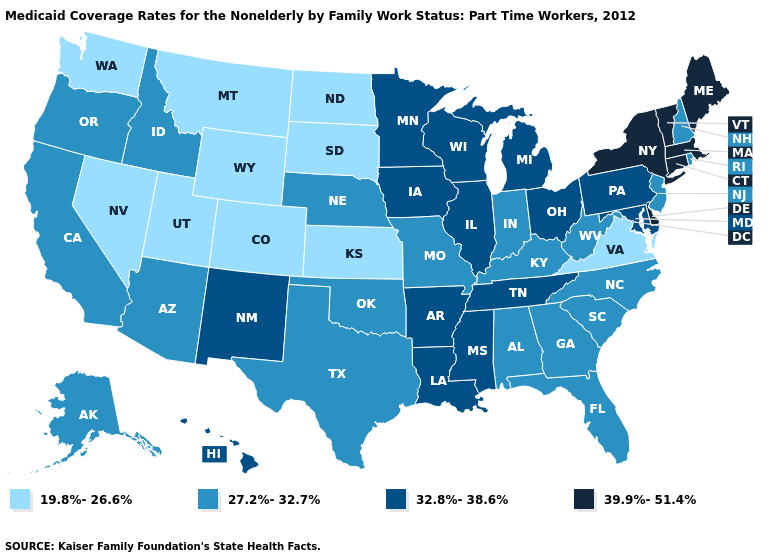Which states hav the highest value in the West?
Be succinct. Hawaii, New Mexico. What is the value of Kansas?
Be succinct. 19.8%-26.6%. What is the lowest value in the USA?
Give a very brief answer. 19.8%-26.6%. Among the states that border Nebraska , does South Dakota have the lowest value?
Write a very short answer. Yes. What is the value of Virginia?
Keep it brief. 19.8%-26.6%. What is the value of Minnesota?
Keep it brief. 32.8%-38.6%. What is the highest value in the USA?
Answer briefly. 39.9%-51.4%. Name the states that have a value in the range 39.9%-51.4%?
Keep it brief. Connecticut, Delaware, Maine, Massachusetts, New York, Vermont. How many symbols are there in the legend?
Short answer required. 4. What is the value of Oklahoma?
Write a very short answer. 27.2%-32.7%. Does Wyoming have the highest value in the USA?
Answer briefly. No. What is the value of Alabama?
Quick response, please. 27.2%-32.7%. What is the value of Washington?
Give a very brief answer. 19.8%-26.6%. Does Virginia have the lowest value in the South?
Give a very brief answer. Yes. 